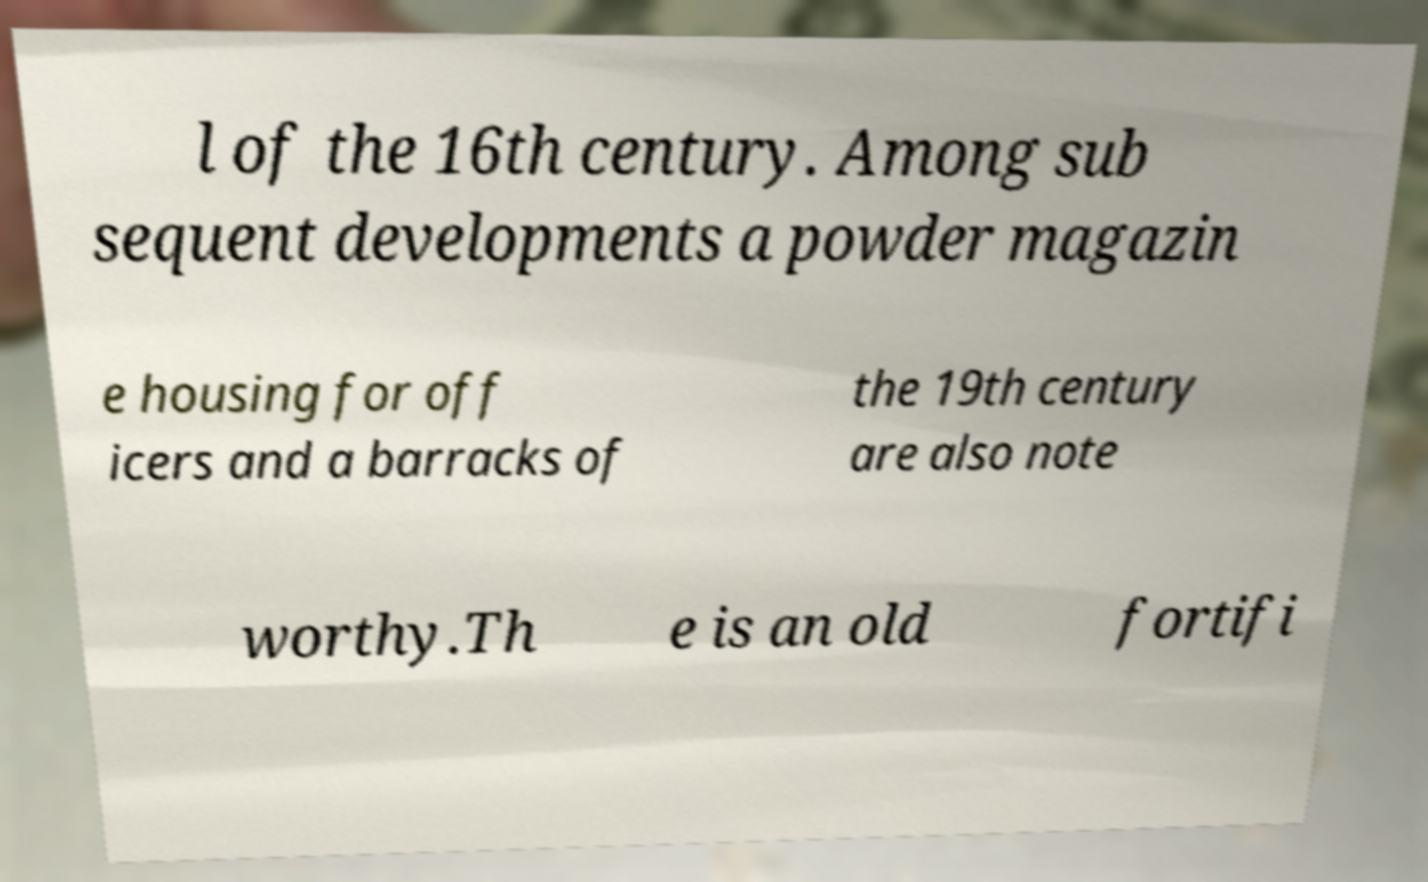Please identify and transcribe the text found in this image. l of the 16th century. Among sub sequent developments a powder magazin e housing for off icers and a barracks of the 19th century are also note worthy.Th e is an old fortifi 